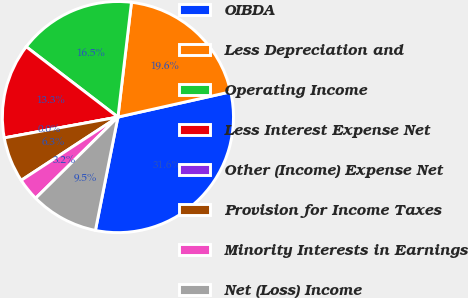Convert chart to OTSL. <chart><loc_0><loc_0><loc_500><loc_500><pie_chart><fcel>OIBDA<fcel>Less Depreciation and<fcel>Operating Income<fcel>Less Interest Expense Net<fcel>Other (Income) Expense Net<fcel>Provision for Income Taxes<fcel>Minority Interests in Earnings<fcel>Net (Loss) Income<nl><fcel>31.63%<fcel>19.62%<fcel>16.46%<fcel>13.3%<fcel>0.0%<fcel>6.33%<fcel>3.17%<fcel>9.49%<nl></chart> 